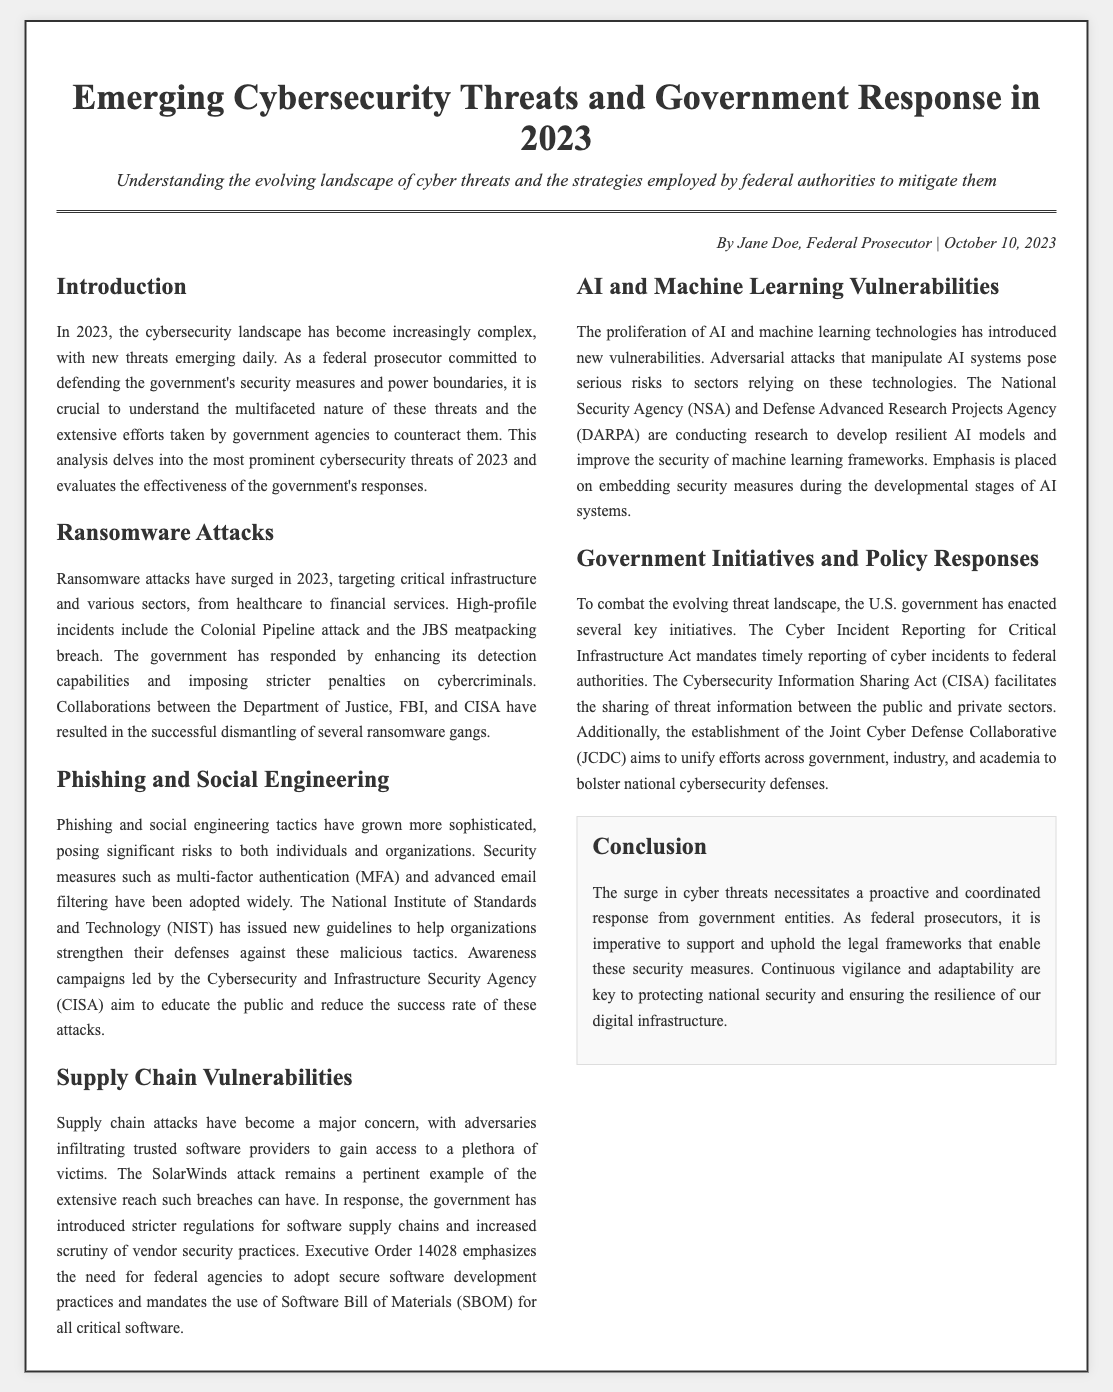What is the publication date of the document? The publication date is mentioned in the byline at the top of the document.
Answer: October 10, 2023 What type of attacks surged in 2023? The document describes various types of cybersecurity attacks and specifically identifies one that has increased significantly.
Answer: Ransomware attacks Which government agencies collaborated to dismantle ransomware gangs? The document mentions specific agencies involved in the collaboration against ransomware attacks.
Answer: Department of Justice, FBI, and CISA What regulation emphasizes secure software development practices? An executive order is referenced as part of the government's response to supply chain vulnerabilities.
Answer: Executive Order 14028 What is the focus of the Cyber Incident Reporting for Critical Infrastructure Act? The document outlines key initiatives from the government in response to emerging threats.
Answer: Timely reporting of cyber incidents What technological advancements introduced new vulnerabilities? The document describes how advancements in a specific technology category have led to increased risks.
Answer: AI and machine learning technologies What does SBOM stand for? The document refers to a necessary component for security in software development without spelling it out.
Answer: Software Bill of Materials What is emphasized as key to protecting national security? The conclusion of the document highlights necessary qualities for effective cybersecurity measures.
Answer: Continuous vigilance and adaptability 